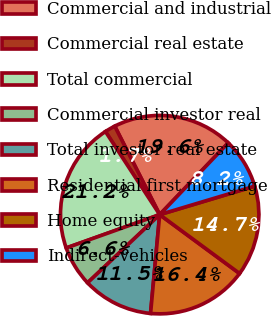Convert chart to OTSL. <chart><loc_0><loc_0><loc_500><loc_500><pie_chart><fcel>Commercial and industrial<fcel>Commercial real estate<fcel>Total commercial<fcel>Commercial investor real<fcel>Total investor real estate<fcel>Residential first mortgage<fcel>Home equity<fcel>Indirect-vehicles<nl><fcel>19.62%<fcel>1.72%<fcel>21.25%<fcel>6.6%<fcel>11.48%<fcel>16.36%<fcel>14.74%<fcel>8.23%<nl></chart> 